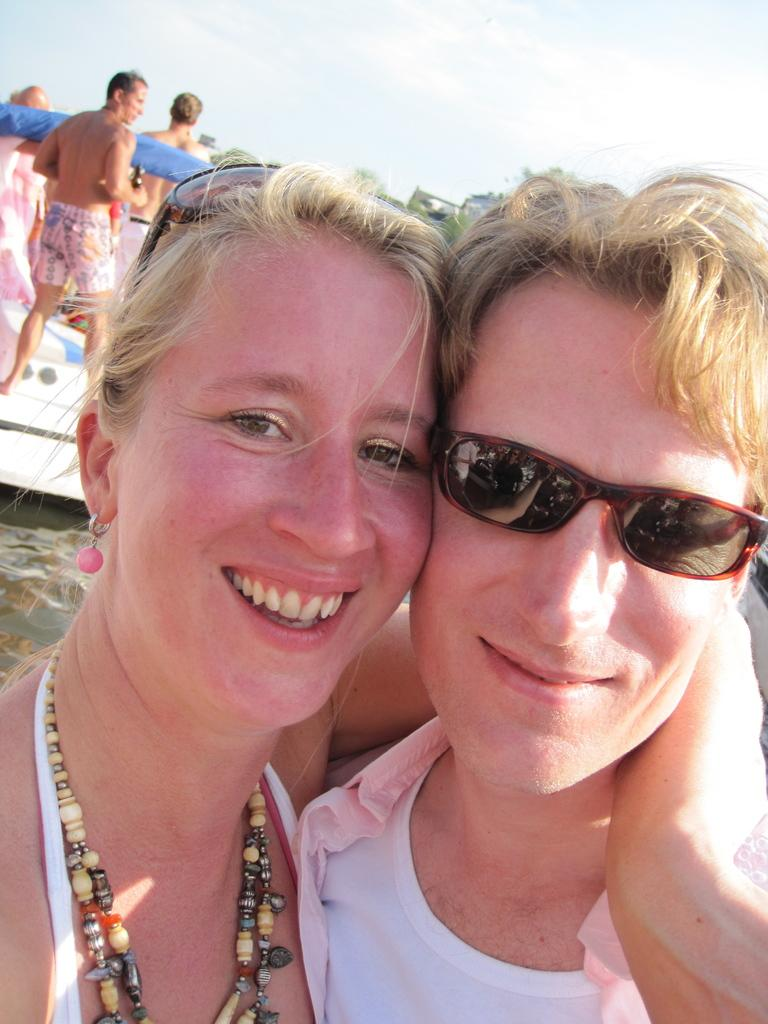How many people are present in the image? There are two people in the image. Can you describe one of the people in the image? One person is wearing sunglasses. Are there any other people visible in the image? Yes, there are other people in the image. What can be seen in the background of the image? The sky is visible in the image. Where is the pencil being used in the image? There is no pencil present in the image. Can you tell me how many rabbits are visible in the image? There are no rabbits visible in the image. 